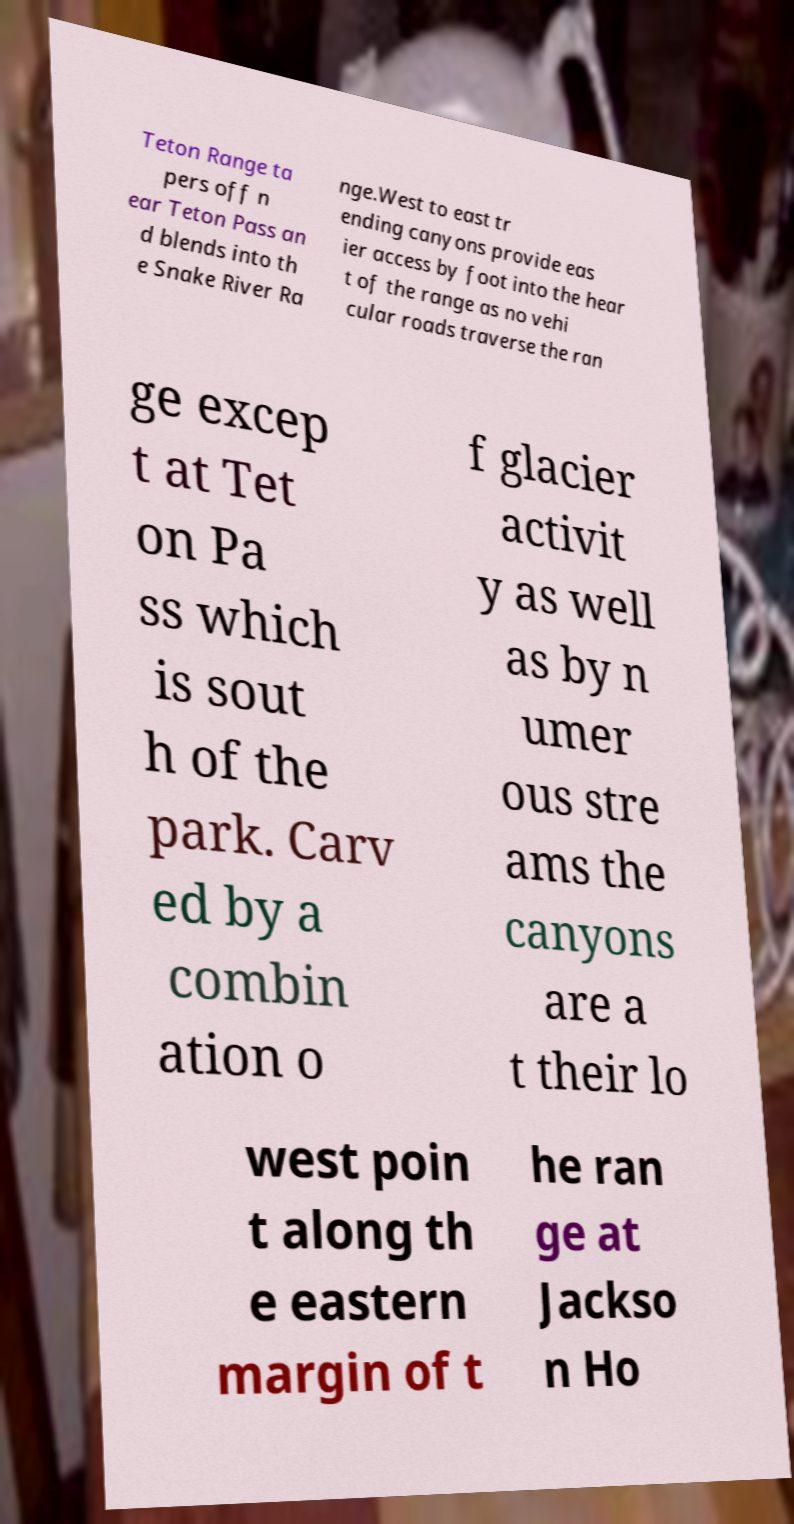Can you read and provide the text displayed in the image?This photo seems to have some interesting text. Can you extract and type it out for me? Teton Range ta pers off n ear Teton Pass an d blends into th e Snake River Ra nge.West to east tr ending canyons provide eas ier access by foot into the hear t of the range as no vehi cular roads traverse the ran ge excep t at Tet on Pa ss which is sout h of the park. Carv ed by a combin ation o f glacier activit y as well as by n umer ous stre ams the canyons are a t their lo west poin t along th e eastern margin of t he ran ge at Jackso n Ho 